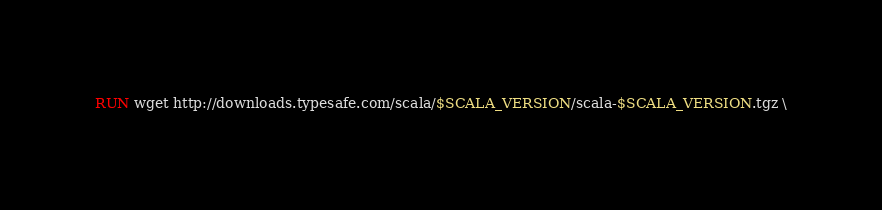<code> <loc_0><loc_0><loc_500><loc_500><_Dockerfile_>RUN wget http://downloads.typesafe.com/scala/$SCALA_VERSION/scala-$SCALA_VERSION.tgz \</code> 